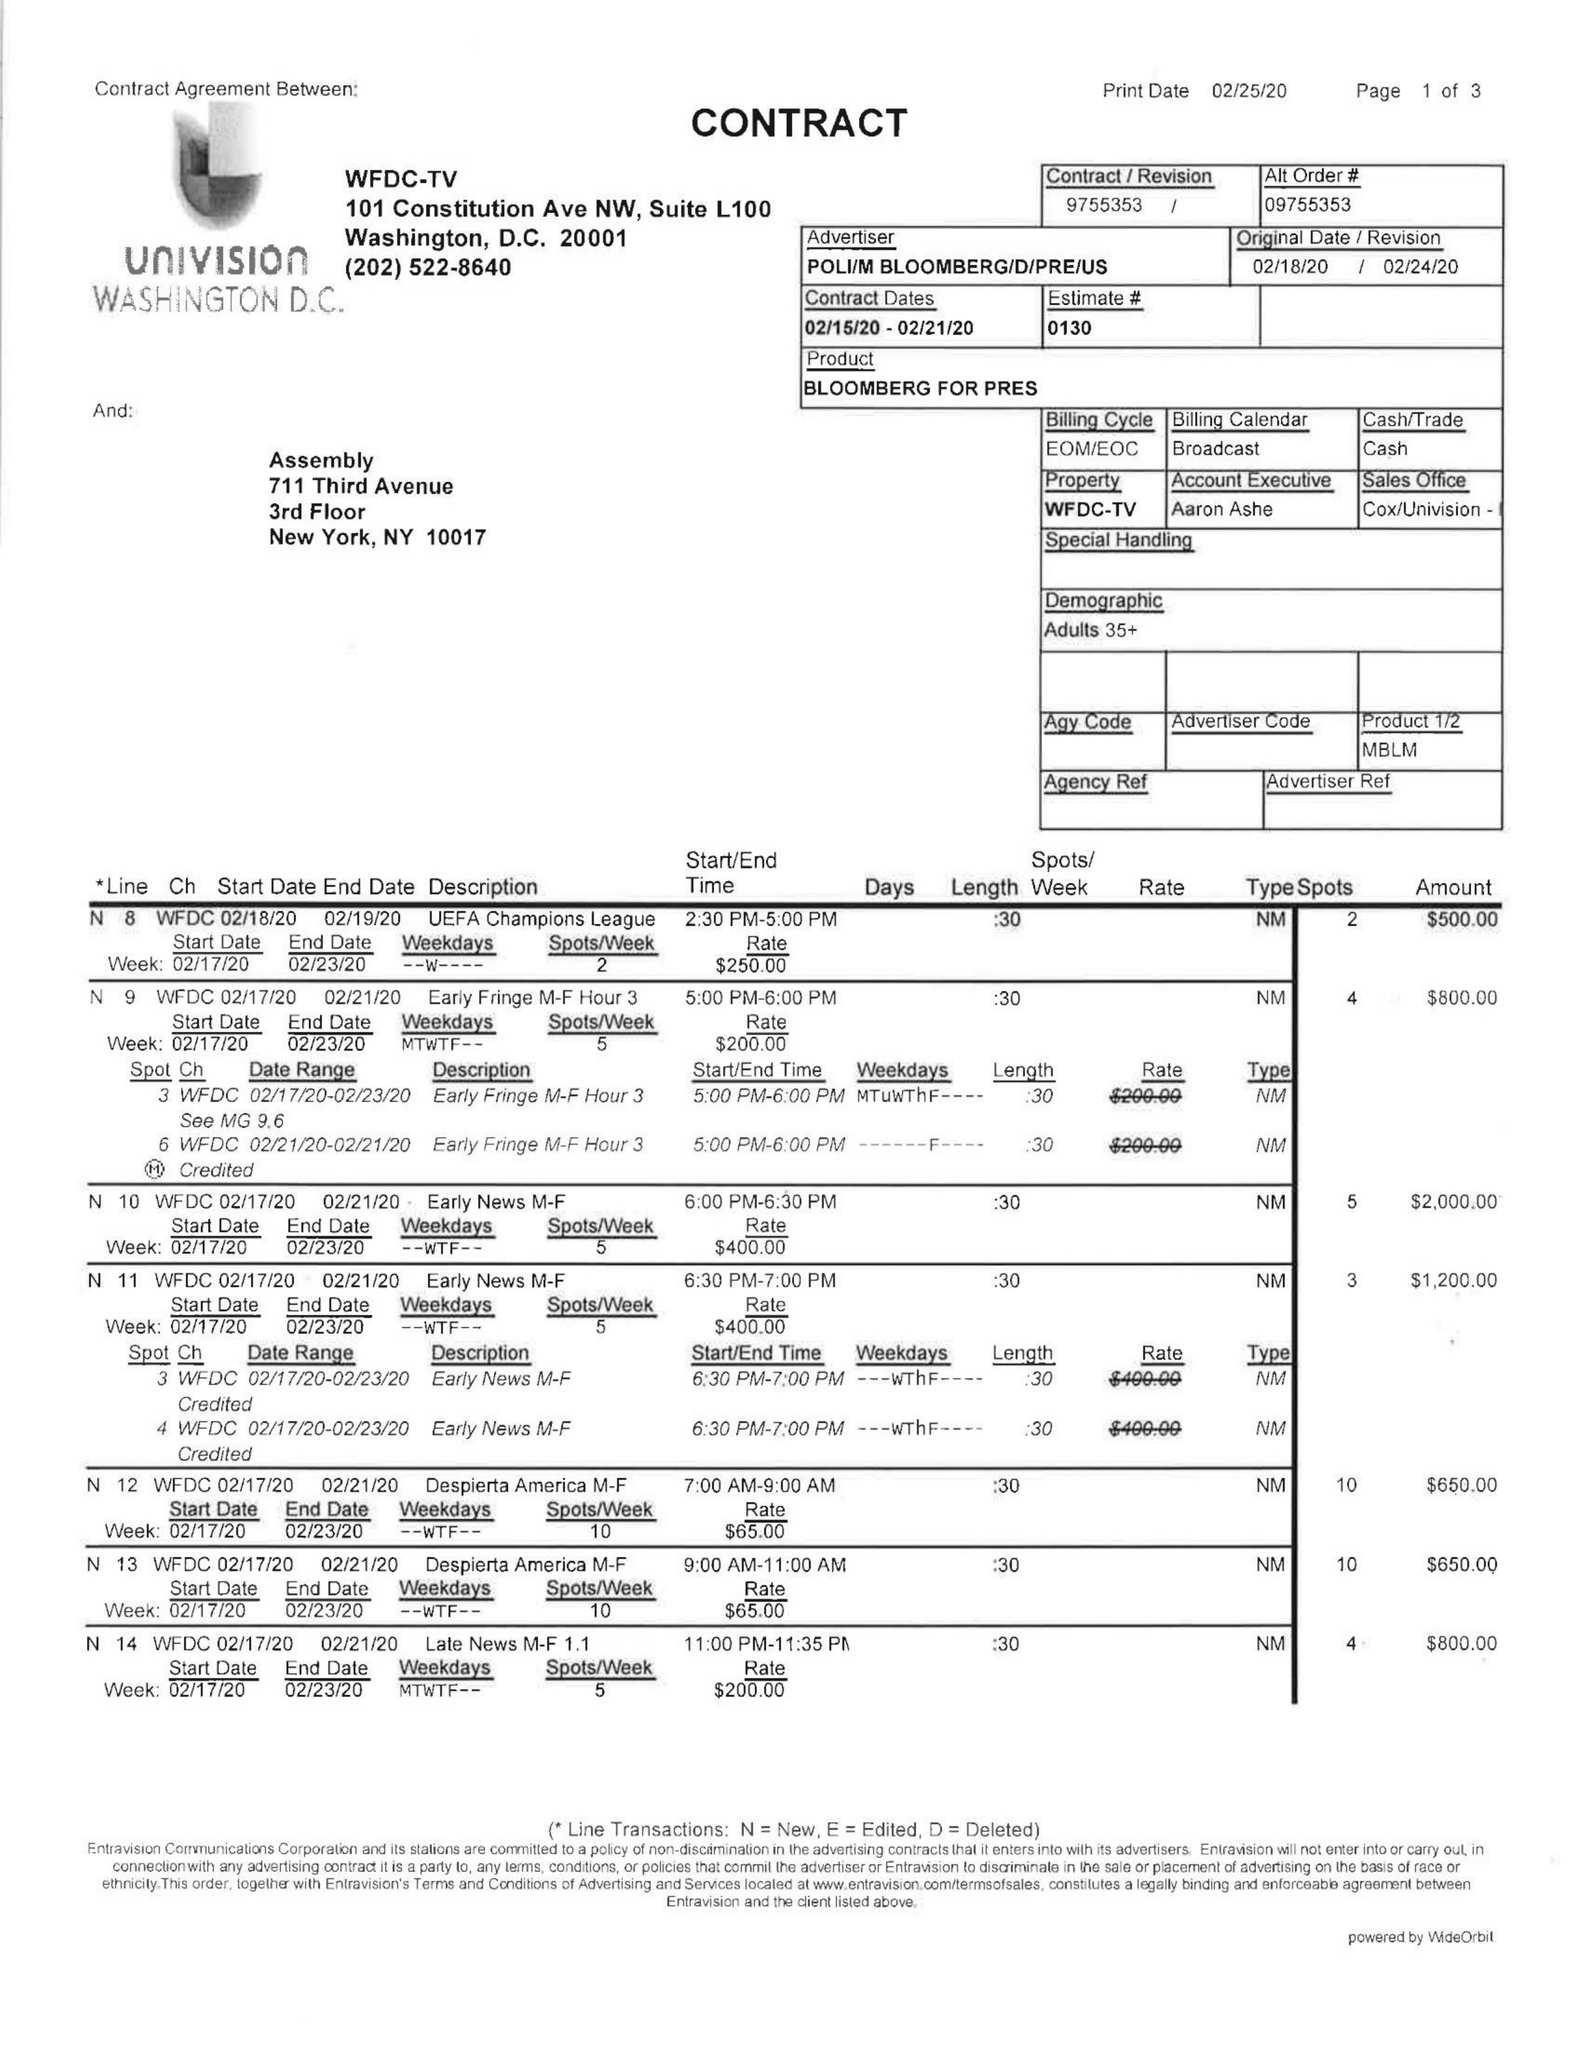What is the value for the advertiser?
Answer the question using a single word or phrase. POLI/MBLOOMBERG/D/PRE/US 